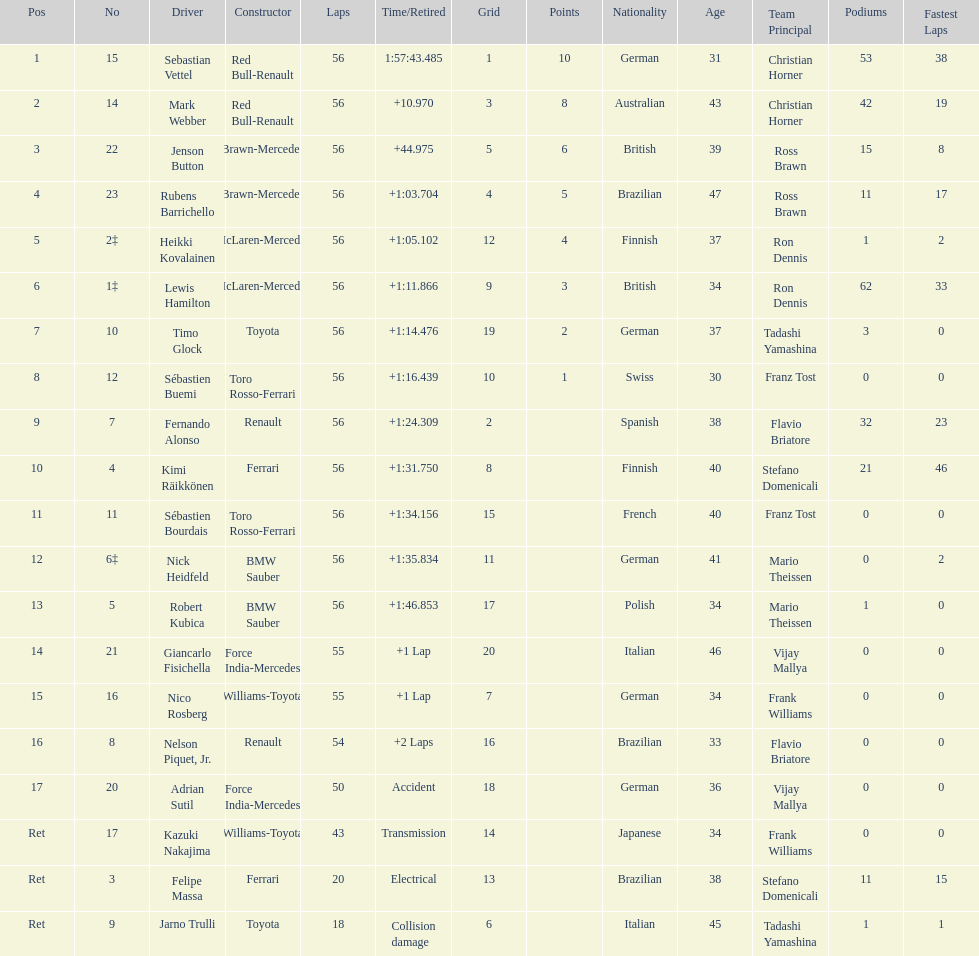What was jenson button's race time? +44.975. 